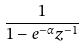<formula> <loc_0><loc_0><loc_500><loc_500>\frac { 1 } { 1 - e ^ { - \alpha } z ^ { - 1 } }</formula> 